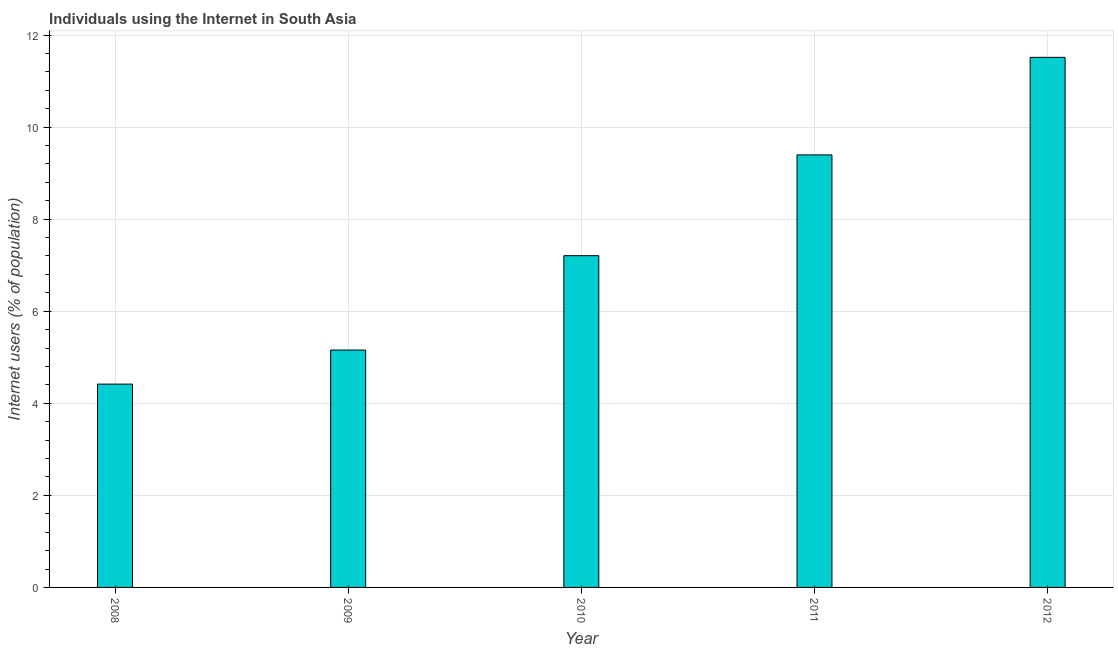Does the graph contain any zero values?
Offer a terse response. No. What is the title of the graph?
Offer a very short reply. Individuals using the Internet in South Asia. What is the label or title of the X-axis?
Ensure brevity in your answer.  Year. What is the label or title of the Y-axis?
Your response must be concise. Internet users (% of population). What is the number of internet users in 2012?
Offer a terse response. 11.52. Across all years, what is the maximum number of internet users?
Ensure brevity in your answer.  11.52. Across all years, what is the minimum number of internet users?
Provide a succinct answer. 4.42. In which year was the number of internet users minimum?
Ensure brevity in your answer.  2008. What is the sum of the number of internet users?
Give a very brief answer. 37.69. What is the difference between the number of internet users in 2009 and 2011?
Your answer should be very brief. -4.24. What is the average number of internet users per year?
Your response must be concise. 7.54. What is the median number of internet users?
Your answer should be very brief. 7.21. What is the ratio of the number of internet users in 2008 to that in 2010?
Provide a short and direct response. 0.61. Is the number of internet users in 2008 less than that in 2010?
Make the answer very short. Yes. What is the difference between the highest and the second highest number of internet users?
Ensure brevity in your answer.  2.12. Is the sum of the number of internet users in 2008 and 2010 greater than the maximum number of internet users across all years?
Make the answer very short. Yes. In how many years, is the number of internet users greater than the average number of internet users taken over all years?
Provide a short and direct response. 2. How many bars are there?
Ensure brevity in your answer.  5. Are all the bars in the graph horizontal?
Offer a terse response. No. How many years are there in the graph?
Your answer should be compact. 5. Are the values on the major ticks of Y-axis written in scientific E-notation?
Your response must be concise. No. What is the Internet users (% of population) in 2008?
Keep it short and to the point. 4.42. What is the Internet users (% of population) of 2009?
Give a very brief answer. 5.16. What is the Internet users (% of population) of 2010?
Keep it short and to the point. 7.21. What is the Internet users (% of population) of 2011?
Make the answer very short. 9.4. What is the Internet users (% of population) of 2012?
Offer a terse response. 11.52. What is the difference between the Internet users (% of population) in 2008 and 2009?
Ensure brevity in your answer.  -0.74. What is the difference between the Internet users (% of population) in 2008 and 2010?
Provide a short and direct response. -2.79. What is the difference between the Internet users (% of population) in 2008 and 2011?
Offer a terse response. -4.98. What is the difference between the Internet users (% of population) in 2008 and 2012?
Ensure brevity in your answer.  -7.1. What is the difference between the Internet users (% of population) in 2009 and 2010?
Give a very brief answer. -2.05. What is the difference between the Internet users (% of population) in 2009 and 2011?
Ensure brevity in your answer.  -4.24. What is the difference between the Internet users (% of population) in 2009 and 2012?
Provide a short and direct response. -6.36. What is the difference between the Internet users (% of population) in 2010 and 2011?
Offer a terse response. -2.19. What is the difference between the Internet users (% of population) in 2010 and 2012?
Your response must be concise. -4.31. What is the difference between the Internet users (% of population) in 2011 and 2012?
Provide a short and direct response. -2.12. What is the ratio of the Internet users (% of population) in 2008 to that in 2009?
Your answer should be compact. 0.86. What is the ratio of the Internet users (% of population) in 2008 to that in 2010?
Give a very brief answer. 0.61. What is the ratio of the Internet users (% of population) in 2008 to that in 2011?
Offer a terse response. 0.47. What is the ratio of the Internet users (% of population) in 2008 to that in 2012?
Provide a succinct answer. 0.38. What is the ratio of the Internet users (% of population) in 2009 to that in 2010?
Your answer should be compact. 0.72. What is the ratio of the Internet users (% of population) in 2009 to that in 2011?
Offer a very short reply. 0.55. What is the ratio of the Internet users (% of population) in 2009 to that in 2012?
Offer a very short reply. 0.45. What is the ratio of the Internet users (% of population) in 2010 to that in 2011?
Provide a succinct answer. 0.77. What is the ratio of the Internet users (% of population) in 2010 to that in 2012?
Your answer should be very brief. 0.63. What is the ratio of the Internet users (% of population) in 2011 to that in 2012?
Ensure brevity in your answer.  0.82. 